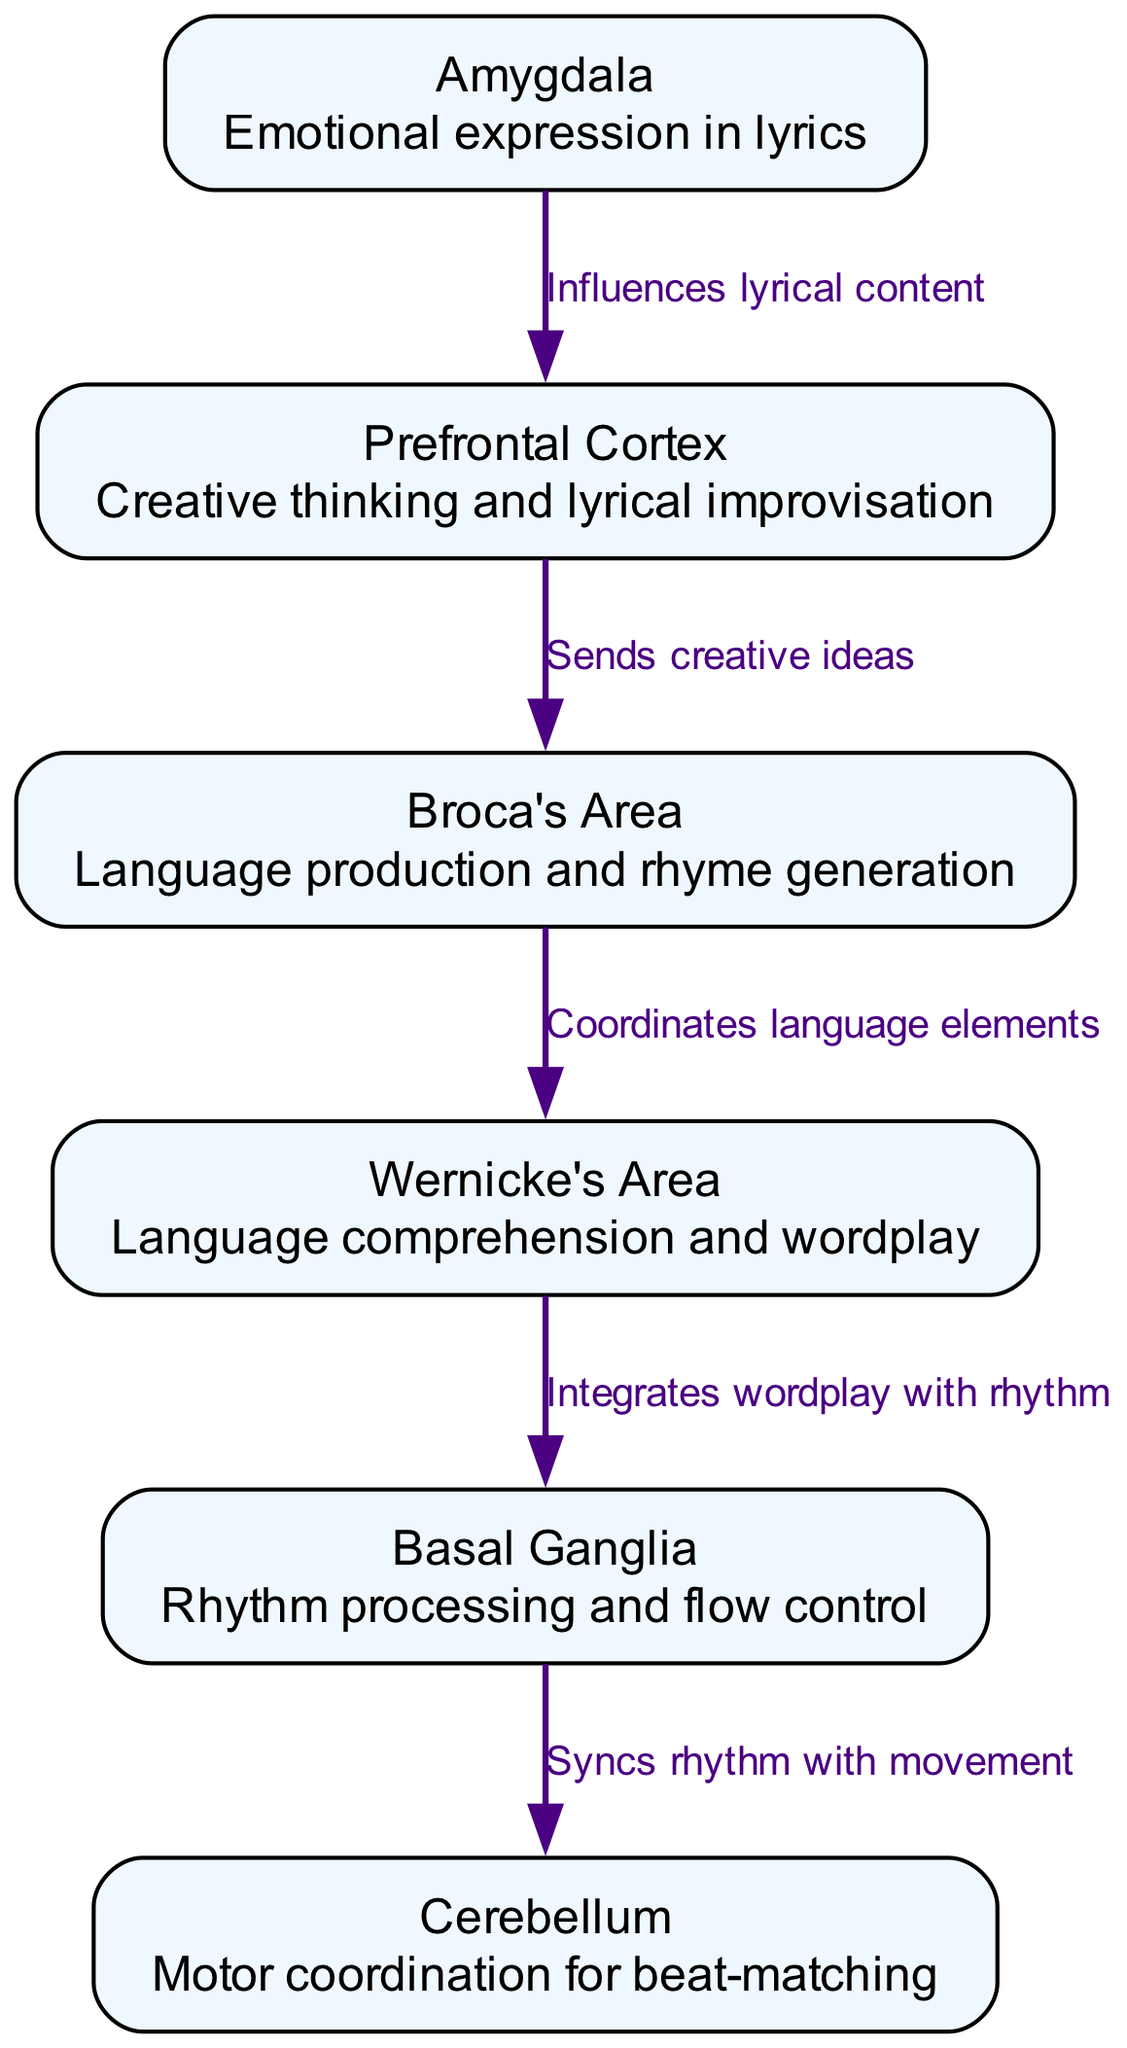What is the function of Broca's Area? Broca's Area is responsible for language production and rhyme generation, as indicated in its description in the diagram.
Answer: Language production and rhyme generation How many nodes are present in the diagram? The diagram contains six nodes representing different neurological areas involved in freestyle rapping.
Answer: 6 Which node sends creative ideas to Broca's Area? The Prefrontal Cortex is directly connected to Broca's Area, as shown by the edge labeled "Sends creative ideas."
Answer: Prefrontal Cortex What is the relationship between Wernicke's Area and the Basal Ganglia? Wernicke's Area integrates wordplay with rhythm, which signifies its connection to the rhythm processing role of the Basal Ganglia, evident from the directed edge labeled "Integrates wordplay with rhythm."
Answer: Integrates wordplay with rhythm Which area influences lyrical content? The diagram shows that the Amygdala influences lyrical content, as indicated by the edge connecting it to the Prefrontal Cortex with the label "Influences lyrical content."
Answer: Amygdala How does the Basal Ganglia interact with the Cerebellum? The connection between Basal Ganglia and Cerebellum involves the synchronization of rhythm with movement, represented in the diagram by the labeled edge "Syncs rhythm with movement."
Answer: Syncs rhythm with movement What role does the Amygdala play in freestyle rapping? The Amygdala's role is to express emotions in lyrics, which is indicated in its description within the diagram.
Answer: Emotional expression in lyrics What node coordinates language elements with Broca's Area? Wernicke's Area coordinates language elements with Broca's Area, as illustrated by the directed edge in the diagram labeled "Coordinates language elements."
Answer: Wernicke's Area 